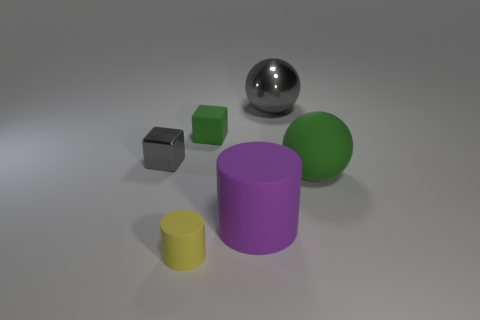Subtract all cylinders. How many objects are left? 4 Subtract all large gray shiny balls. Subtract all big gray things. How many objects are left? 4 Add 4 blocks. How many blocks are left? 6 Add 4 gray shiny objects. How many gray shiny objects exist? 6 Add 3 big purple cubes. How many objects exist? 9 Subtract all purple cylinders. How many cylinders are left? 1 Subtract 0 cyan blocks. How many objects are left? 6 Subtract 1 cylinders. How many cylinders are left? 1 Subtract all blue cylinders. Subtract all green blocks. How many cylinders are left? 2 Subtract all yellow balls. How many cyan cylinders are left? 0 